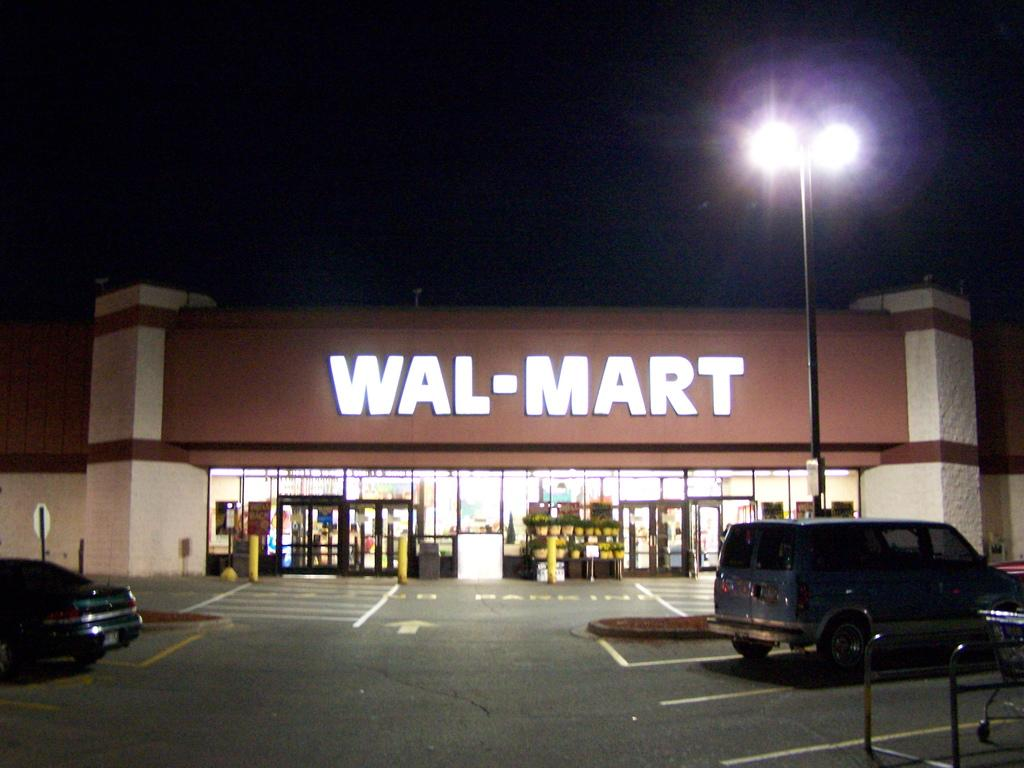<image>
Give a short and clear explanation of the subsequent image. Wal-Mart sign all lite up in the dark of night. 